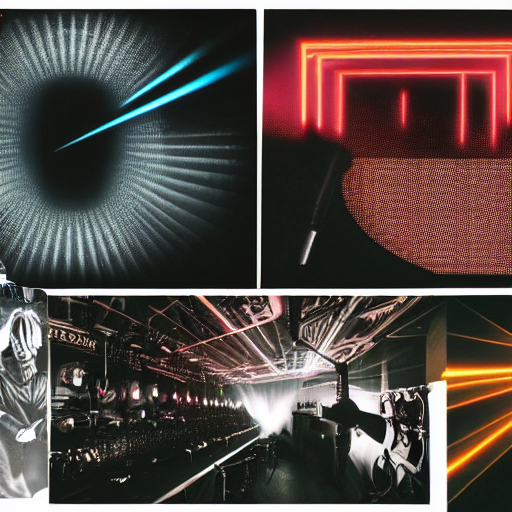What kind of mood or atmosphere do these images convey? The images convey a modern, dynamic, and somewhat futuristic atmosphere. The use of vibrant neon colors, intense lighting effects, and sleek designs conjure a sense of advanced technology and high energy. These visuals could be associated with themes of innovation, nightlife, and high-tech environments. 